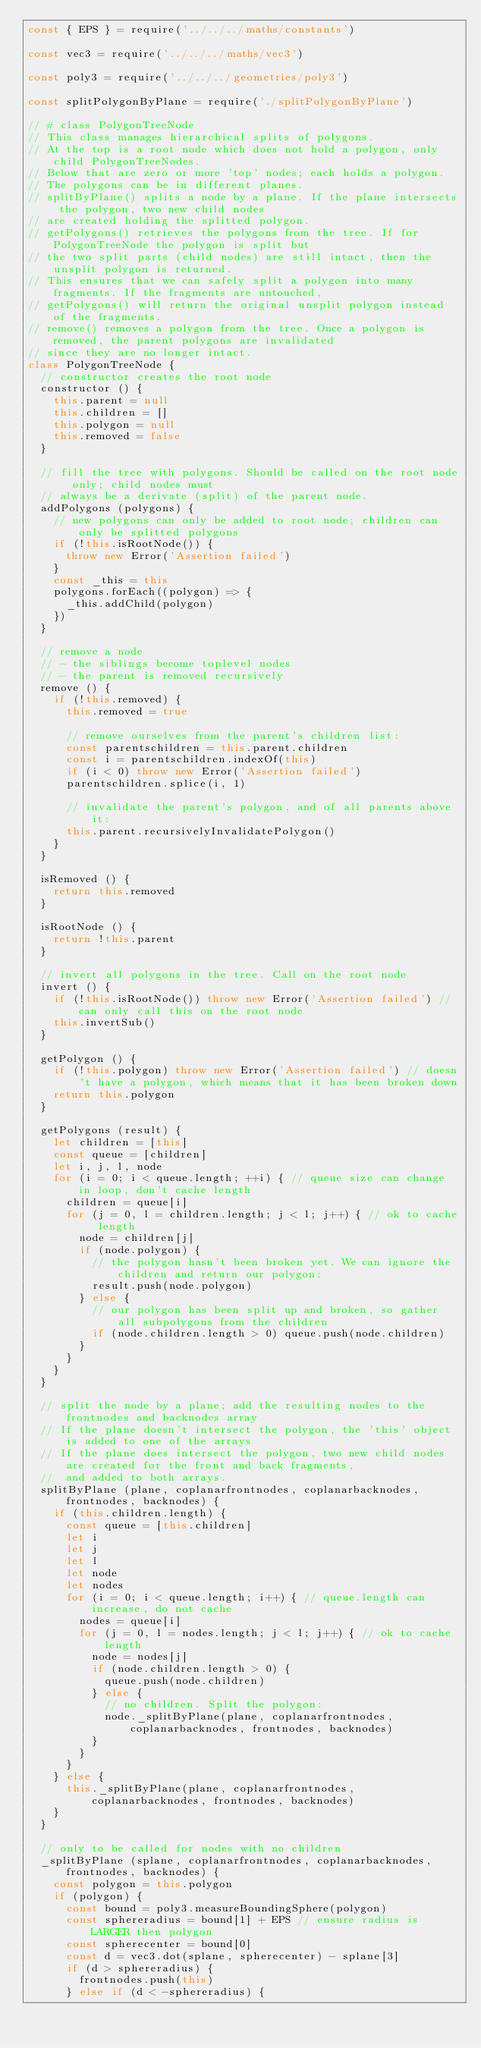Convert code to text. <code><loc_0><loc_0><loc_500><loc_500><_JavaScript_>const { EPS } = require('../../../maths/constants')

const vec3 = require('../../../maths/vec3')

const poly3 = require('../../../geometries/poly3')

const splitPolygonByPlane = require('./splitPolygonByPlane')

// # class PolygonTreeNode
// This class manages hierarchical splits of polygons.
// At the top is a root node which does not hold a polygon, only child PolygonTreeNodes.
// Below that are zero or more 'top' nodes; each holds a polygon.
// The polygons can be in different planes.
// splitByPlane() splits a node by a plane. If the plane intersects the polygon, two new child nodes
// are created holding the splitted polygon.
// getPolygons() retrieves the polygons from the tree. If for PolygonTreeNode the polygon is split but
// the two split parts (child nodes) are still intact, then the unsplit polygon is returned.
// This ensures that we can safely split a polygon into many fragments. If the fragments are untouched,
// getPolygons() will return the original unsplit polygon instead of the fragments.
// remove() removes a polygon from the tree. Once a polygon is removed, the parent polygons are invalidated
// since they are no longer intact.
class PolygonTreeNode {
  // constructor creates the root node
  constructor () {
    this.parent = null
    this.children = []
    this.polygon = null
    this.removed = false
  }

  // fill the tree with polygons. Should be called on the root node only; child nodes must
  // always be a derivate (split) of the parent node.
  addPolygons (polygons) {
    // new polygons can only be added to root node; children can only be splitted polygons
    if (!this.isRootNode()) {
      throw new Error('Assertion failed')
    }
    const _this = this
    polygons.forEach((polygon) => {
      _this.addChild(polygon)
    })
  }

  // remove a node
  // - the siblings become toplevel nodes
  // - the parent is removed recursively
  remove () {
    if (!this.removed) {
      this.removed = true

      // remove ourselves from the parent's children list:
      const parentschildren = this.parent.children
      const i = parentschildren.indexOf(this)
      if (i < 0) throw new Error('Assertion failed')
      parentschildren.splice(i, 1)

      // invalidate the parent's polygon, and of all parents above it:
      this.parent.recursivelyInvalidatePolygon()
    }
  }

  isRemoved () {
    return this.removed
  }

  isRootNode () {
    return !this.parent
  }

  // invert all polygons in the tree. Call on the root node
  invert () {
    if (!this.isRootNode()) throw new Error('Assertion failed') // can only call this on the root node
    this.invertSub()
  }

  getPolygon () {
    if (!this.polygon) throw new Error('Assertion failed') // doesn't have a polygon, which means that it has been broken down
    return this.polygon
  }

  getPolygons (result) {
    let children = [this]
    const queue = [children]
    let i, j, l, node
    for (i = 0; i < queue.length; ++i) { // queue size can change in loop, don't cache length
      children = queue[i]
      for (j = 0, l = children.length; j < l; j++) { // ok to cache length
        node = children[j]
        if (node.polygon) {
          // the polygon hasn't been broken yet. We can ignore the children and return our polygon:
          result.push(node.polygon)
        } else {
          // our polygon has been split up and broken, so gather all subpolygons from the children
          if (node.children.length > 0) queue.push(node.children)
        }
      }
    }
  }

  // split the node by a plane; add the resulting nodes to the frontnodes and backnodes array
  // If the plane doesn't intersect the polygon, the 'this' object is added to one of the arrays
  // If the plane does intersect the polygon, two new child nodes are created for the front and back fragments,
  //  and added to both arrays.
  splitByPlane (plane, coplanarfrontnodes, coplanarbacknodes, frontnodes, backnodes) {
    if (this.children.length) {
      const queue = [this.children]
      let i
      let j
      let l
      let node
      let nodes
      for (i = 0; i < queue.length; i++) { // queue.length can increase, do not cache
        nodes = queue[i]
        for (j = 0, l = nodes.length; j < l; j++) { // ok to cache length
          node = nodes[j]
          if (node.children.length > 0) {
            queue.push(node.children)
          } else {
            // no children. Split the polygon:
            node._splitByPlane(plane, coplanarfrontnodes, coplanarbacknodes, frontnodes, backnodes)
          }
        }
      }
    } else {
      this._splitByPlane(plane, coplanarfrontnodes, coplanarbacknodes, frontnodes, backnodes)
    }
  }

  // only to be called for nodes with no children
  _splitByPlane (splane, coplanarfrontnodes, coplanarbacknodes, frontnodes, backnodes) {
    const polygon = this.polygon
    if (polygon) {
      const bound = poly3.measureBoundingSphere(polygon)
      const sphereradius = bound[1] + EPS // ensure radius is LARGER then polygon
      const spherecenter = bound[0]
      const d = vec3.dot(splane, spherecenter) - splane[3]
      if (d > sphereradius) {
        frontnodes.push(this)
      } else if (d < -sphereradius) {</code> 